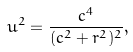Convert formula to latex. <formula><loc_0><loc_0><loc_500><loc_500>u ^ { 2 } = \frac { c ^ { 4 } } { ( c ^ { 2 } + r ^ { 2 } ) ^ { 2 } } ,</formula> 